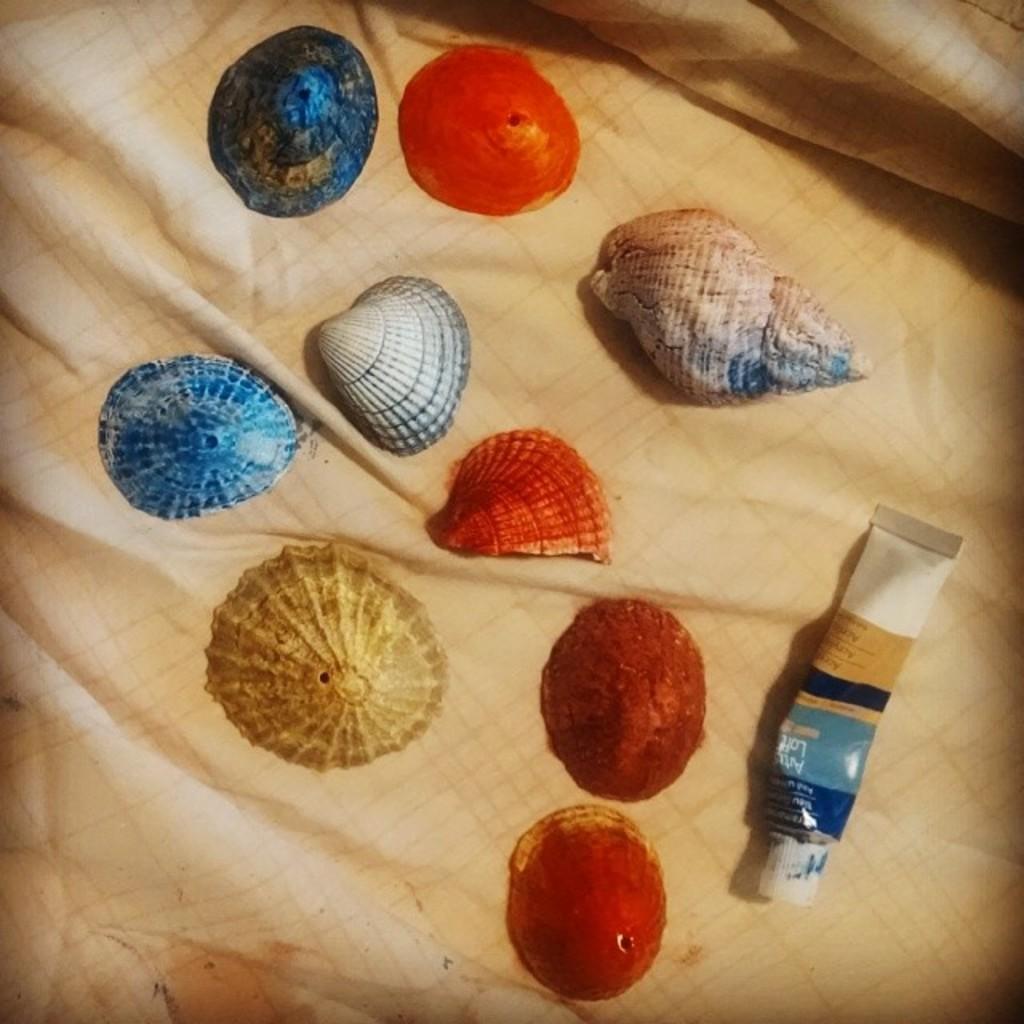How would you summarize this image in a sentence or two? In this image, we can see shells and a tube on a cloth. 